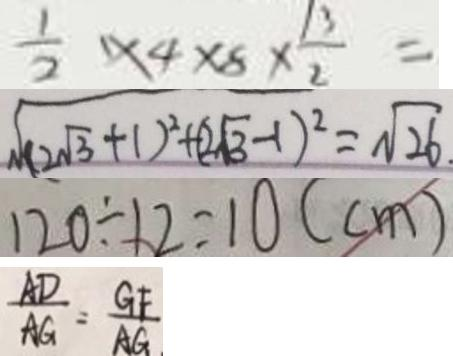Convert formula to latex. <formula><loc_0><loc_0><loc_500><loc_500>\frac { 1 } { 2 } \times 4 \times 8 \times \frac { 1 3 } { 2 } = 
 \sqrt { ( 2 \sqrt { 3 } + 1 ) ^ { 2 } + ( 2 \sqrt { 3 } - 1 ) ^ { 2 } } = \sqrt { 2 6 } 
 1 2 0 \div 1 2 = 1 0 ( c m ) 
 \frac { A D } { A G } = \frac { G F } { A G }</formula> 